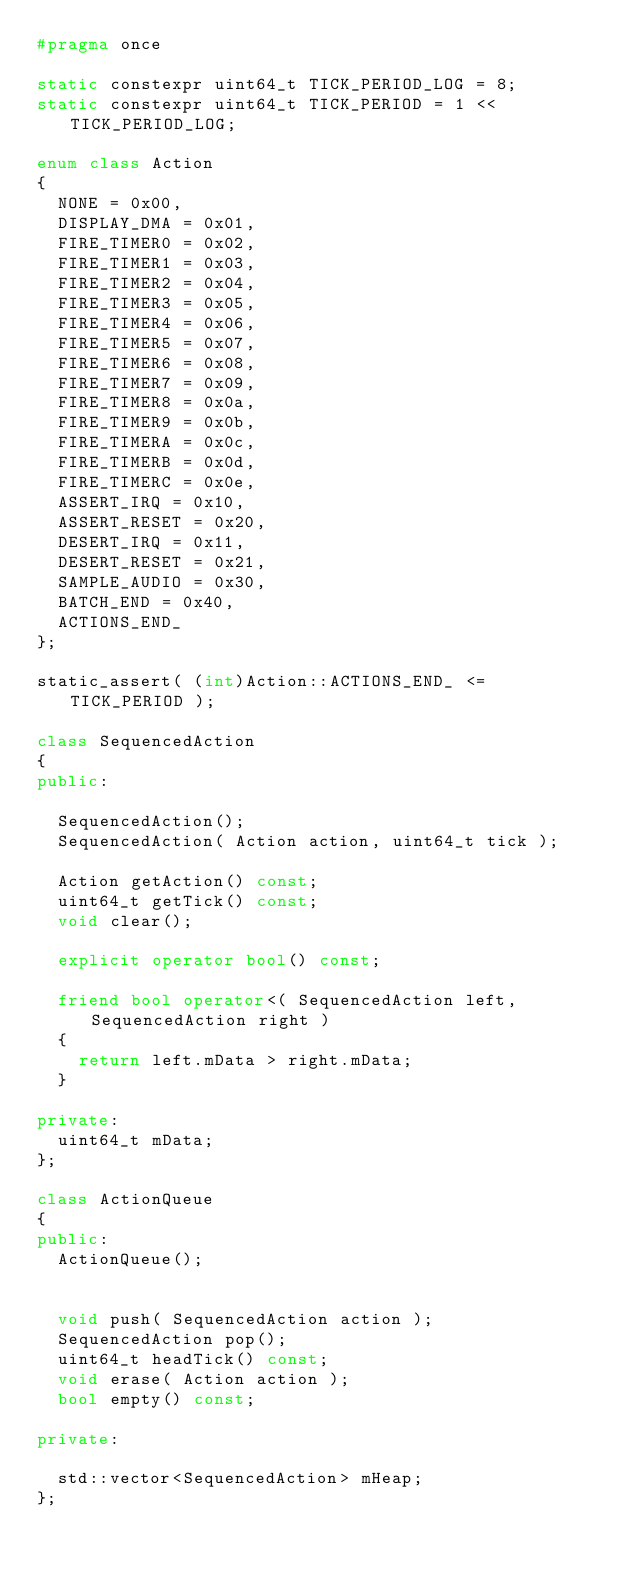Convert code to text. <code><loc_0><loc_0><loc_500><loc_500><_C++_>#pragma once

static constexpr uint64_t TICK_PERIOD_LOG = 8;
static constexpr uint64_t TICK_PERIOD = 1 << TICK_PERIOD_LOG;

enum class Action
{
  NONE = 0x00,
  DISPLAY_DMA = 0x01,
  FIRE_TIMER0 = 0x02,
  FIRE_TIMER1 = 0x03,
  FIRE_TIMER2 = 0x04,
  FIRE_TIMER3 = 0x05,
  FIRE_TIMER4 = 0x06,
  FIRE_TIMER5 = 0x07,
  FIRE_TIMER6 = 0x08,
  FIRE_TIMER7 = 0x09,
  FIRE_TIMER8 = 0x0a,
  FIRE_TIMER9 = 0x0b,
  FIRE_TIMERA = 0x0c,
  FIRE_TIMERB = 0x0d,
  FIRE_TIMERC = 0x0e,
  ASSERT_IRQ = 0x10,
  ASSERT_RESET = 0x20,
  DESERT_IRQ = 0x11,
  DESERT_RESET = 0x21,
  SAMPLE_AUDIO = 0x30,
  BATCH_END = 0x40,
  ACTIONS_END_
};

static_assert( (int)Action::ACTIONS_END_ <= TICK_PERIOD );

class SequencedAction
{
public:

  SequencedAction();
  SequencedAction( Action action, uint64_t tick );

  Action getAction() const;
  uint64_t getTick() const;
  void clear();

  explicit operator bool() const;

  friend bool operator<( SequencedAction left, SequencedAction right )
  {
    return left.mData > right.mData;
  }

private:
  uint64_t mData;
};

class ActionQueue
{
public:
  ActionQueue();


  void push( SequencedAction action );
  SequencedAction pop();
  uint64_t headTick() const;
  void erase( Action action );
  bool empty() const;

private:

  std::vector<SequencedAction> mHeap;
};

</code> 